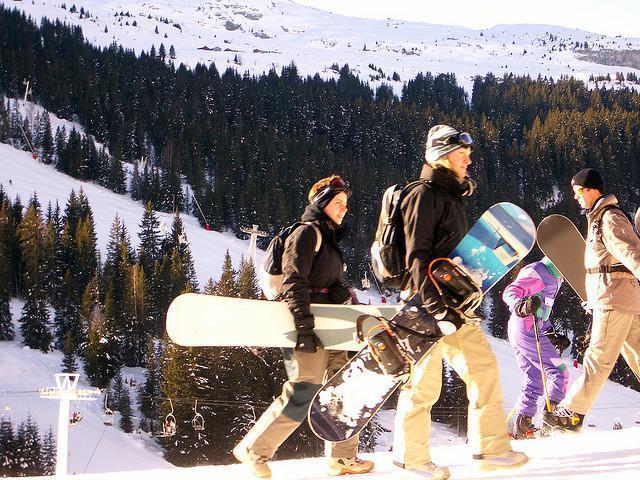What are these people in the front carrying?
Select the accurate response from the four choices given to answer the question.
Options: Snowboards, surfboards, skates, skateboards. Snowboards. 